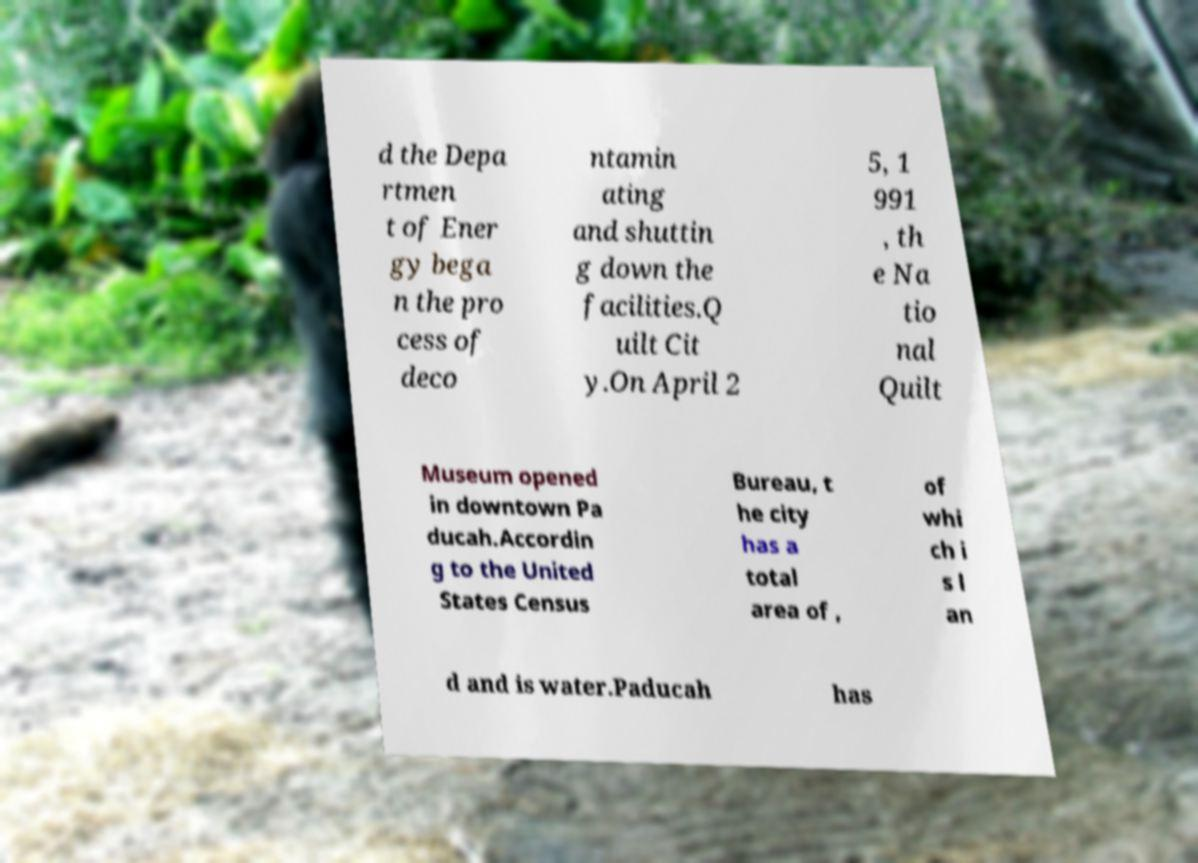Please identify and transcribe the text found in this image. d the Depa rtmen t of Ener gy bega n the pro cess of deco ntamin ating and shuttin g down the facilities.Q uilt Cit y.On April 2 5, 1 991 , th e Na tio nal Quilt Museum opened in downtown Pa ducah.Accordin g to the United States Census Bureau, t he city has a total area of , of whi ch i s l an d and is water.Paducah has 